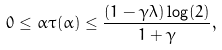Convert formula to latex. <formula><loc_0><loc_0><loc_500><loc_500>0 \leq \alpha \tau ( \alpha ) \leq \frac { ( 1 - \gamma \lambda ) \log ( 2 ) } { 1 + \gamma } ,</formula> 